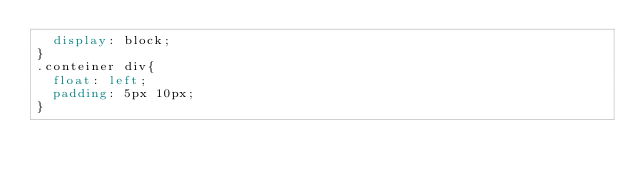<code> <loc_0><loc_0><loc_500><loc_500><_CSS_>  display: block;
}
.conteiner div{
  float: left;
  padding: 5px 10px;
}
</code> 